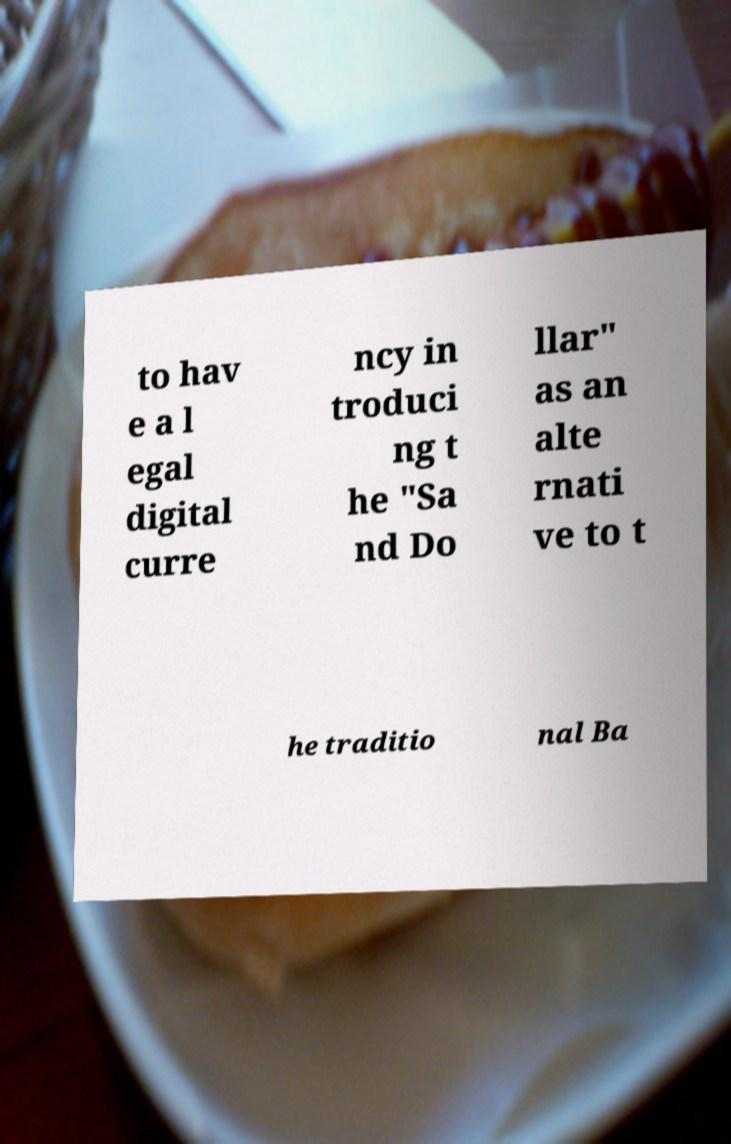Please read and relay the text visible in this image. What does it say? to hav e a l egal digital curre ncy in troduci ng t he "Sa nd Do llar" as an alte rnati ve to t he traditio nal Ba 